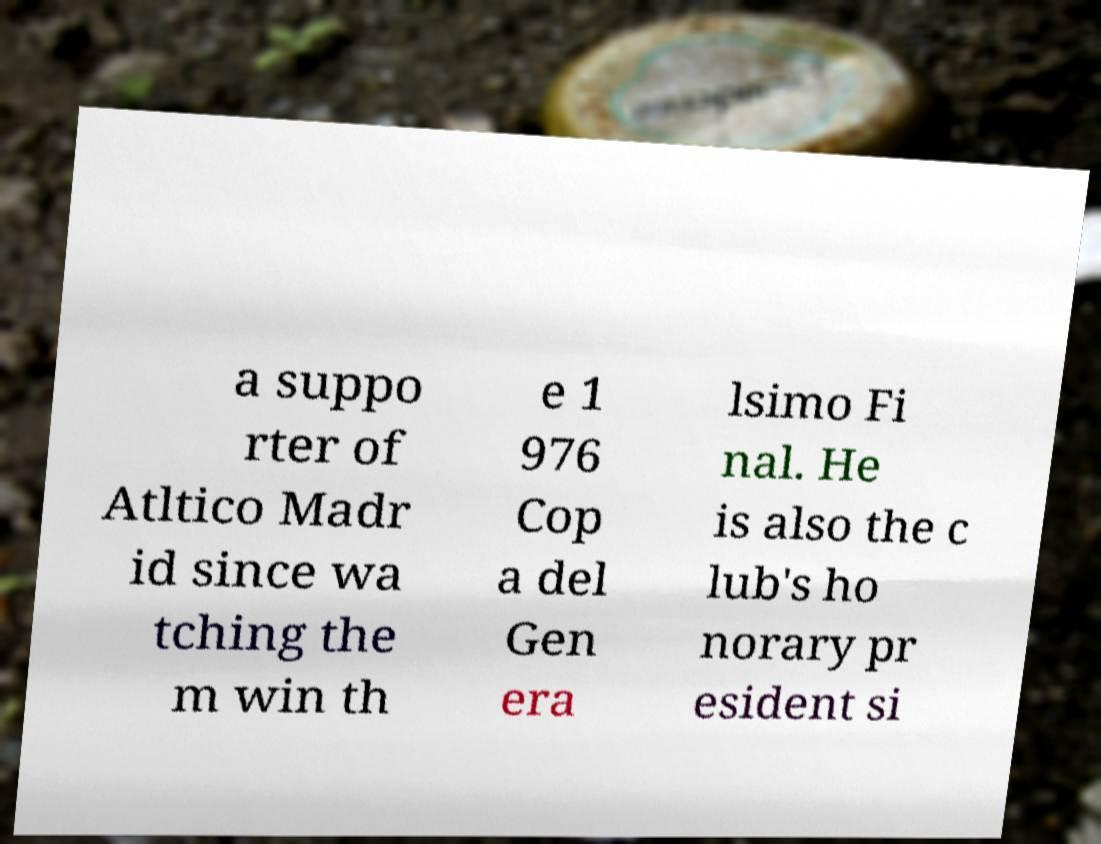There's text embedded in this image that I need extracted. Can you transcribe it verbatim? a suppo rter of Atltico Madr id since wa tching the m win th e 1 976 Cop a del Gen era lsimo Fi nal. He is also the c lub's ho norary pr esident si 